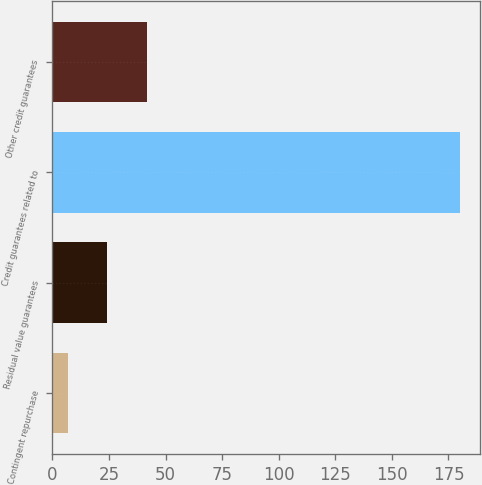Convert chart. <chart><loc_0><loc_0><loc_500><loc_500><bar_chart><fcel>Contingent repurchase<fcel>Residual value guarantees<fcel>Credit guarantees related to<fcel>Other credit guarantees<nl><fcel>7<fcel>24.3<fcel>180<fcel>41.6<nl></chart> 